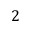Convert formula to latex. <formula><loc_0><loc_0><loc_500><loc_500>2</formula> 